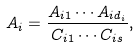<formula> <loc_0><loc_0><loc_500><loc_500>A _ { i } = \frac { A _ { i 1 } \cdots A _ { i d _ { i } } } { C _ { i 1 } \cdots C _ { i s } } ,</formula> 